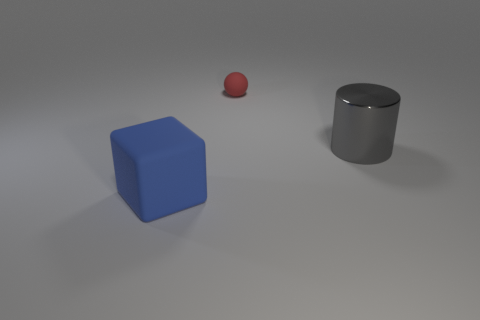Add 1 metal things. How many objects exist? 4 Subtract all cylinders. How many objects are left? 2 Subtract all red blocks. Subtract all red cylinders. How many blocks are left? 1 Subtract all green spheres. How many red blocks are left? 0 Subtract all large yellow rubber spheres. Subtract all large gray cylinders. How many objects are left? 2 Add 3 large cylinders. How many large cylinders are left? 4 Add 1 small red objects. How many small red objects exist? 2 Subtract 0 purple cylinders. How many objects are left? 3 